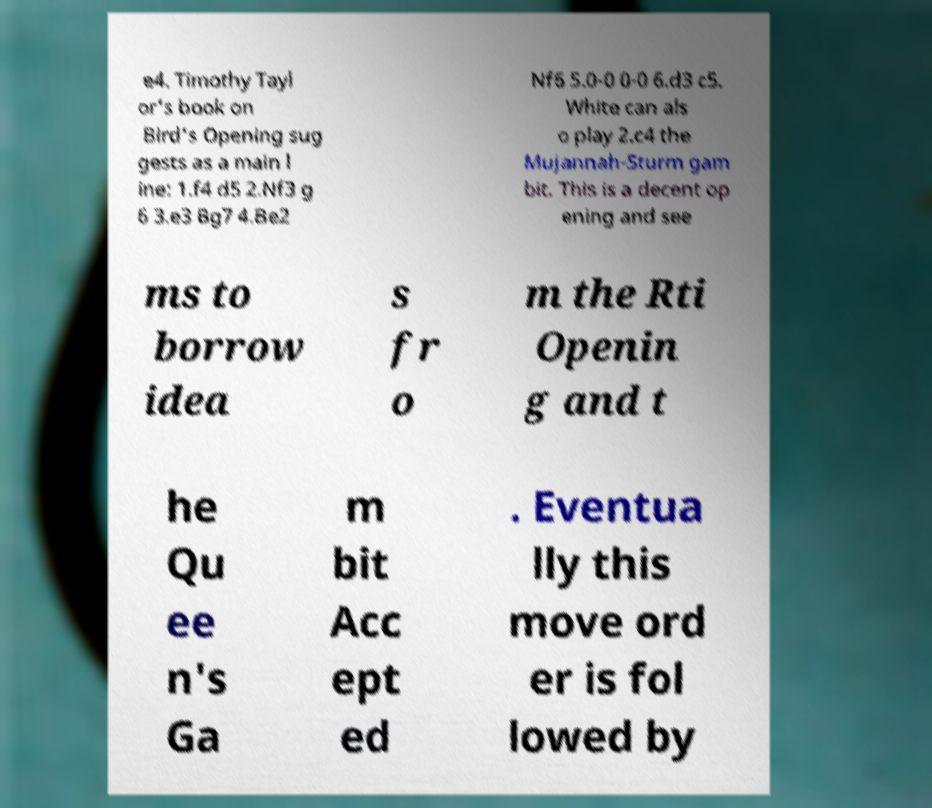Please read and relay the text visible in this image. What does it say? e4. Timothy Tayl or's book on Bird's Opening sug gests as a main l ine: 1.f4 d5 2.Nf3 g 6 3.e3 Bg7 4.Be2 Nf6 5.0-0 0-0 6.d3 c5. White can als o play 2.c4 the Mujannah-Sturm gam bit. This is a decent op ening and see ms to borrow idea s fr o m the Rti Openin g and t he Qu ee n's Ga m bit Acc ept ed . Eventua lly this move ord er is fol lowed by 